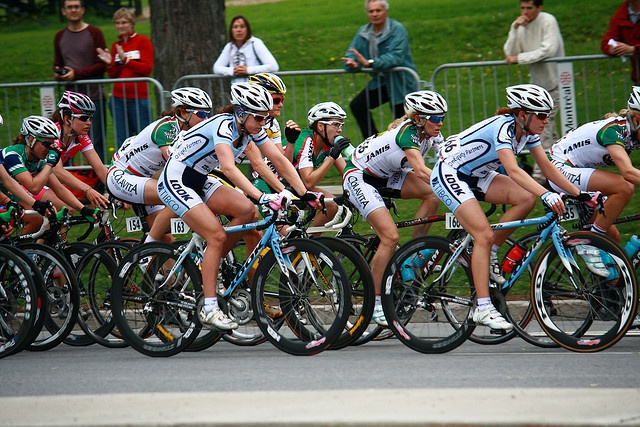Describe the objects in this image and their specific colors. I can see bicycle in black, gray, darkgray, and darkgreen tones, bicycle in black, gray, darkgray, and maroon tones, people in black, brown, white, and maroon tones, people in black, white, brown, and lightpink tones, and people in black, lavender, brown, and maroon tones in this image. 